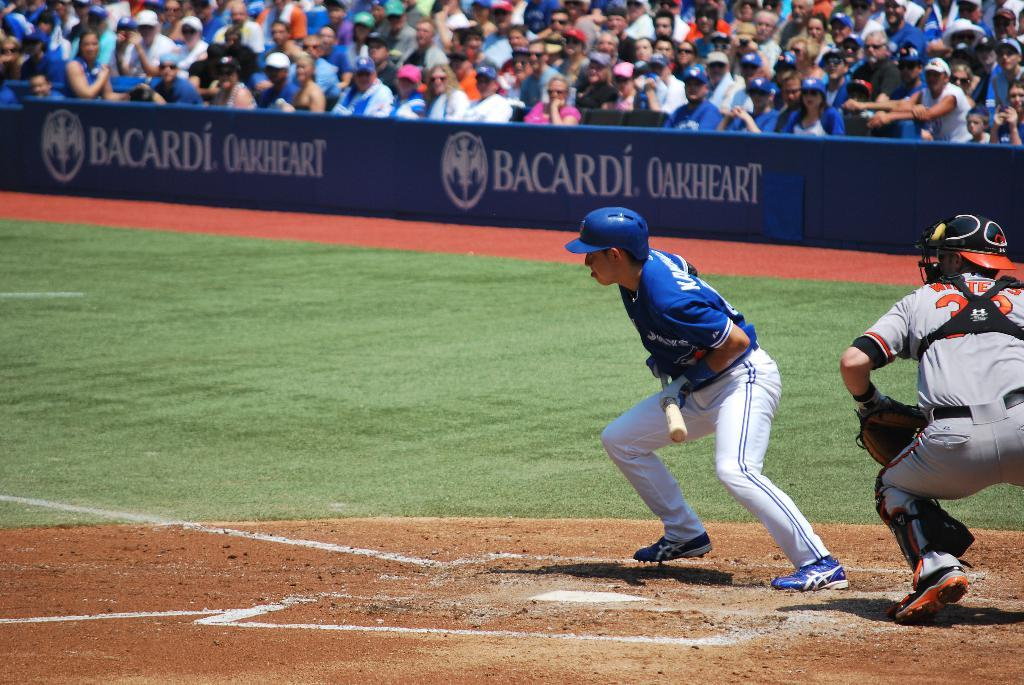Provide a one-sentence caption for the provided image. A few baseball players waiting to bat with Bacardi as a sponser. 